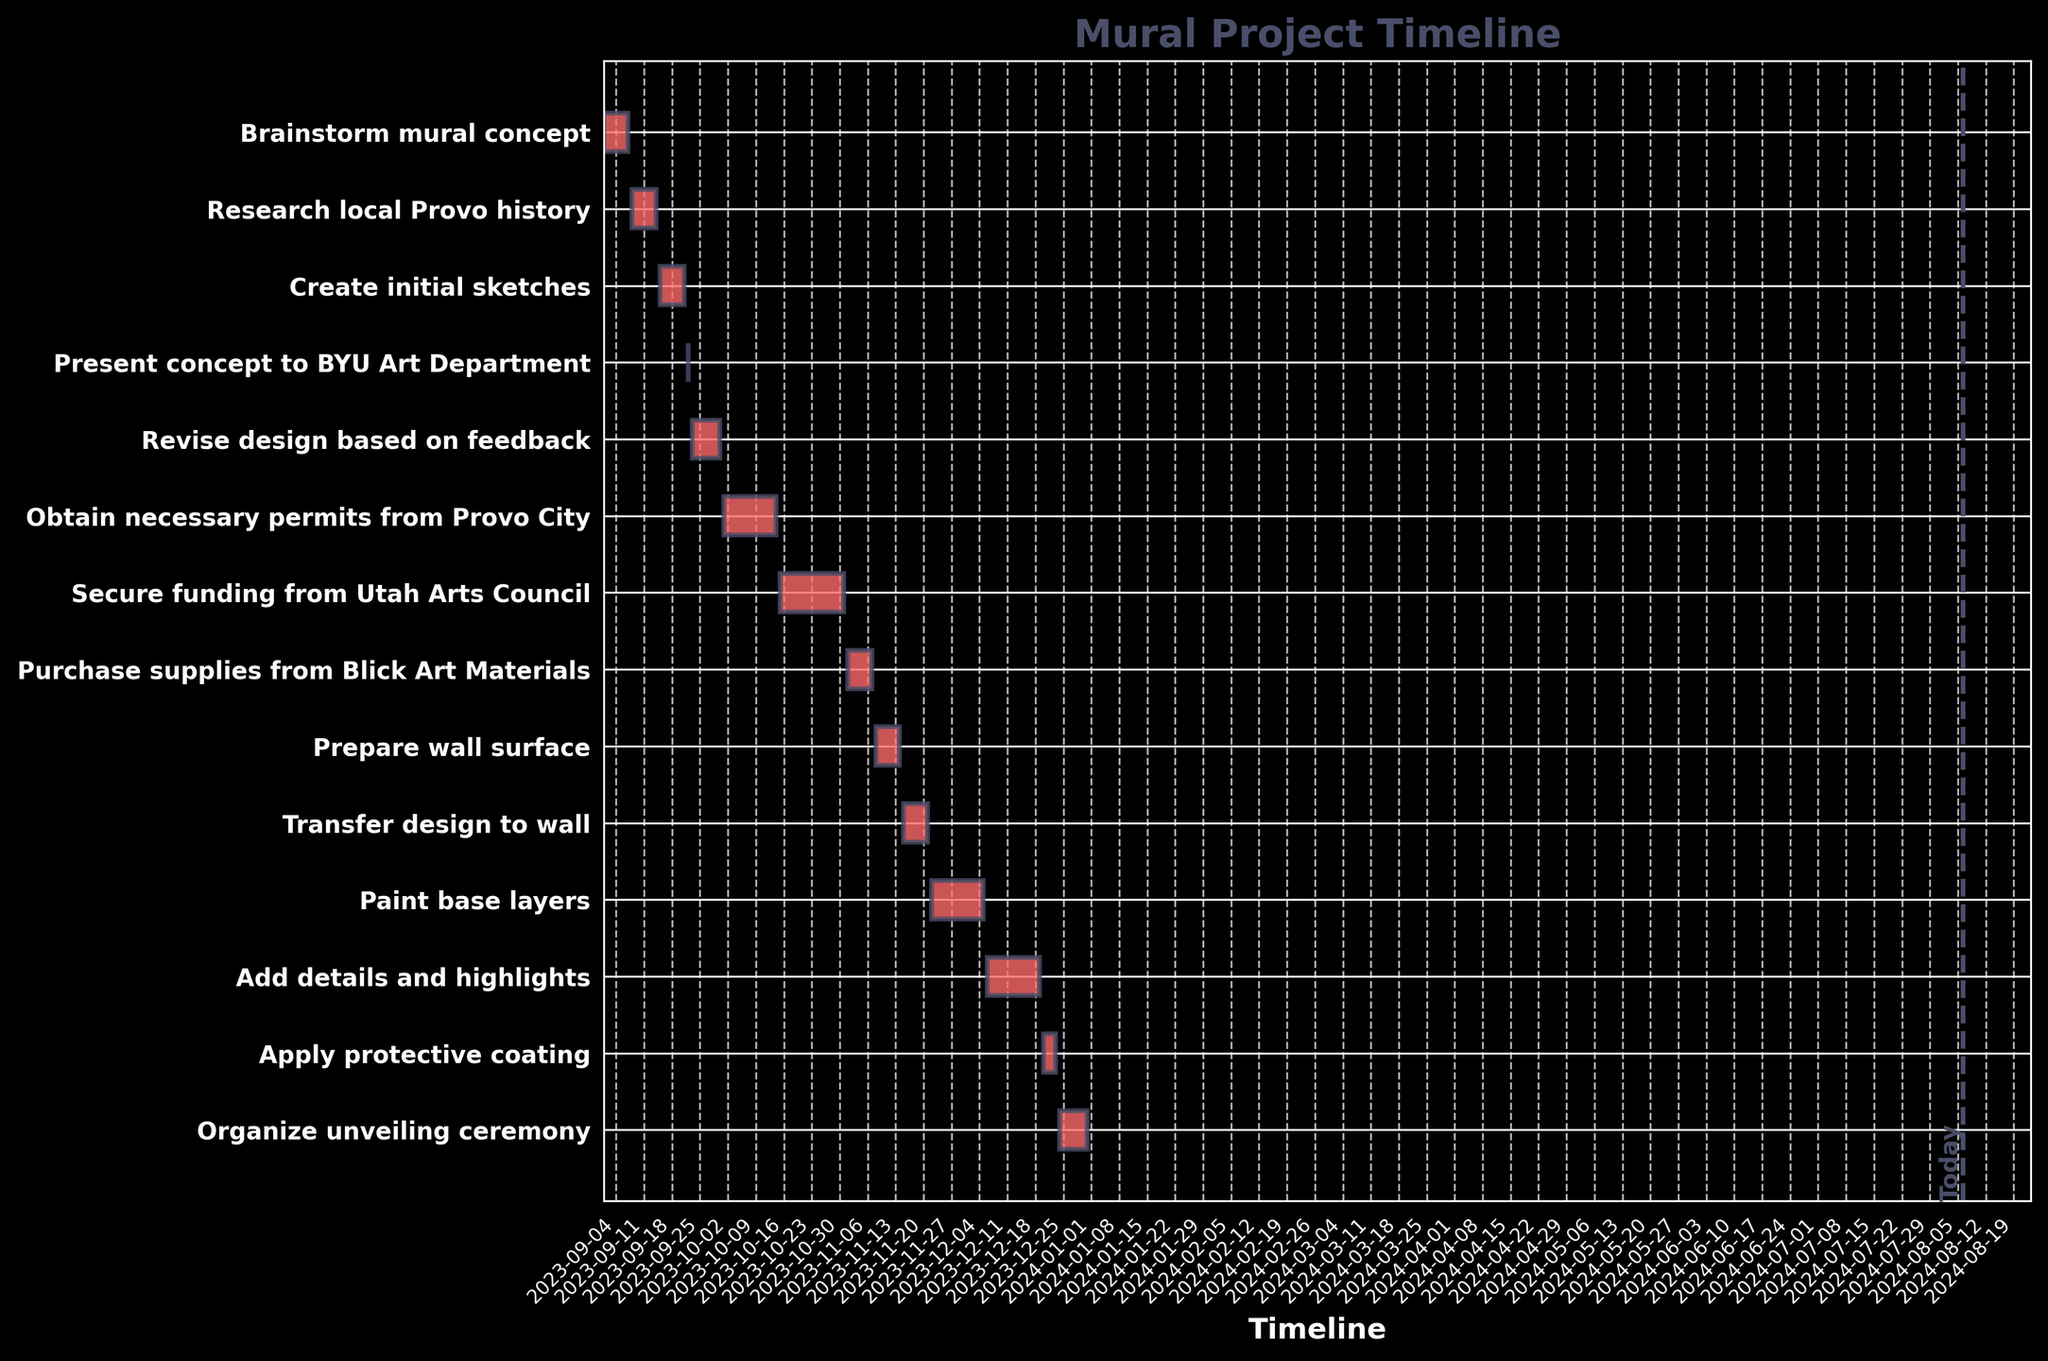What is the title of the Gantt chart? The title is located at the top of the Gantt chart and usually signifies the main subject of the chart. In this case, "Mural Project Timeline" is the title indicating the progression of the mural project.
Answer: Mural Project Timeline During which dates is the "Create initial sketches" task scheduled? Look along the y-axis to find the "Create initial sketches" task and then check the corresponding horizontal bar to see the date range along the x-axis. It spans from "2023-09-15" to "2023-09-21".
Answer: 2023-09-15 to 2023-09-21 Which task has the longest duration, and how many days does it cover? Compare the length of all horizontal bars to determine which one is longest. The "Paint base layers" task spans from "2023-11-22" to "2023-12-05". Calculate the duration as follows: 2023-12-05 minus 2023-11-22 equals 14 days.
Answer: Paint base layers, 14 days Which tasks are scheduled to start after "2023-11-01" and before "2023-12-01"? Identify tasks with start dates between "2023-11-01" and "2023-12-01" by looking at the x-axis timeline. The tasks are "Purchase supplies from Blick Art Materials" (starting on "2023-11-01"), "Prepare wall surface" (starting on "2023-11-08"), "Transfer design to wall" (starting on "2023-11-15"), and "Paint base layers" (starting on "2023-11-22").
Answer: Purchase supplies from Blick Art Materials, Prepare wall surface, Transfer design to wall, Paint base layers How many tasks take place in the month of October, and which ones are they? Look at the tasks and their corresponding date ranges on the x-axis. Tasks that take place in October are those with date ranges falling within 2023-10-01 to 2023-10-31. The tasks are "Obtain necessary permits from Provo City" and "Secure funding from Utah Arts Council."
Answer: 2 tasks, Obtain necessary permits from Provo City, Secure funding from Utah Arts Council Which task immediately follows the "Present concept to BYU Art Department"? Identify the "Present concept to BYU Art Department" task on the y-axis, and locate the task that has its start date immediately after the end date of "2023-09-22". The next task is "Revise design based on feedback," which starts on "2023-09-23".
Answer: Revise design based on feedback How long is the total duration from the start of "Brainstorm mural concept" to the end of "Organize unveiling ceremony"? Check the start date of the first task ("Brainstorm mural concept" starting on "2023-09-01") and the end date of the last task ("Organize unveiling ceremony" ending on "2023-12-31"). Calculate the total duration as December 31 minus September 1.
Answer: 122 days What are the last two tasks before the "Organize unveiling ceremony"? Examine the tasks scheduled just before "Organize unveiling ceremony" (the last task). The two tasks before it are "Apply protective coating" (from "2023-12-20" to "2023-12-23") and "Add details and highlights" (from "2023-12-06" to "2023-12-19").
Answer: Apply protective coating, Add details and highlights Are there any tasks that start and end within the same day? If so, which one(s)? Look for tasks where the start and end dates are identical by checking the bars with the shortest length. "Present concept to BYU Art Department" starts and ends on "2023-09-22".
Answer: Present concept to BYU Art Department 